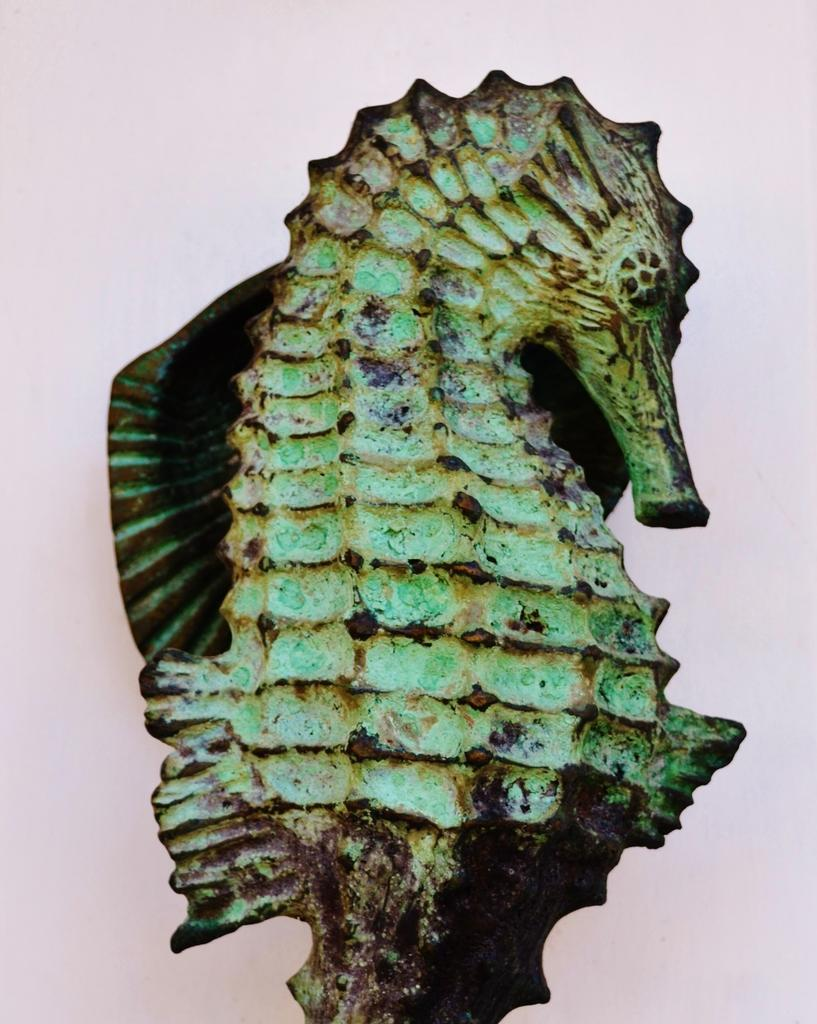What is the main subject of the image? The main subject of the image is a sculpture of a seahorse. What type of beef is being cooked in the image? There is no beef present in the image; it features a sculpture of a seahorse. What color is the pen used to draw the seahorse in the image? There is no pen or drawing of a seahorse in the image; it is a sculpture. 